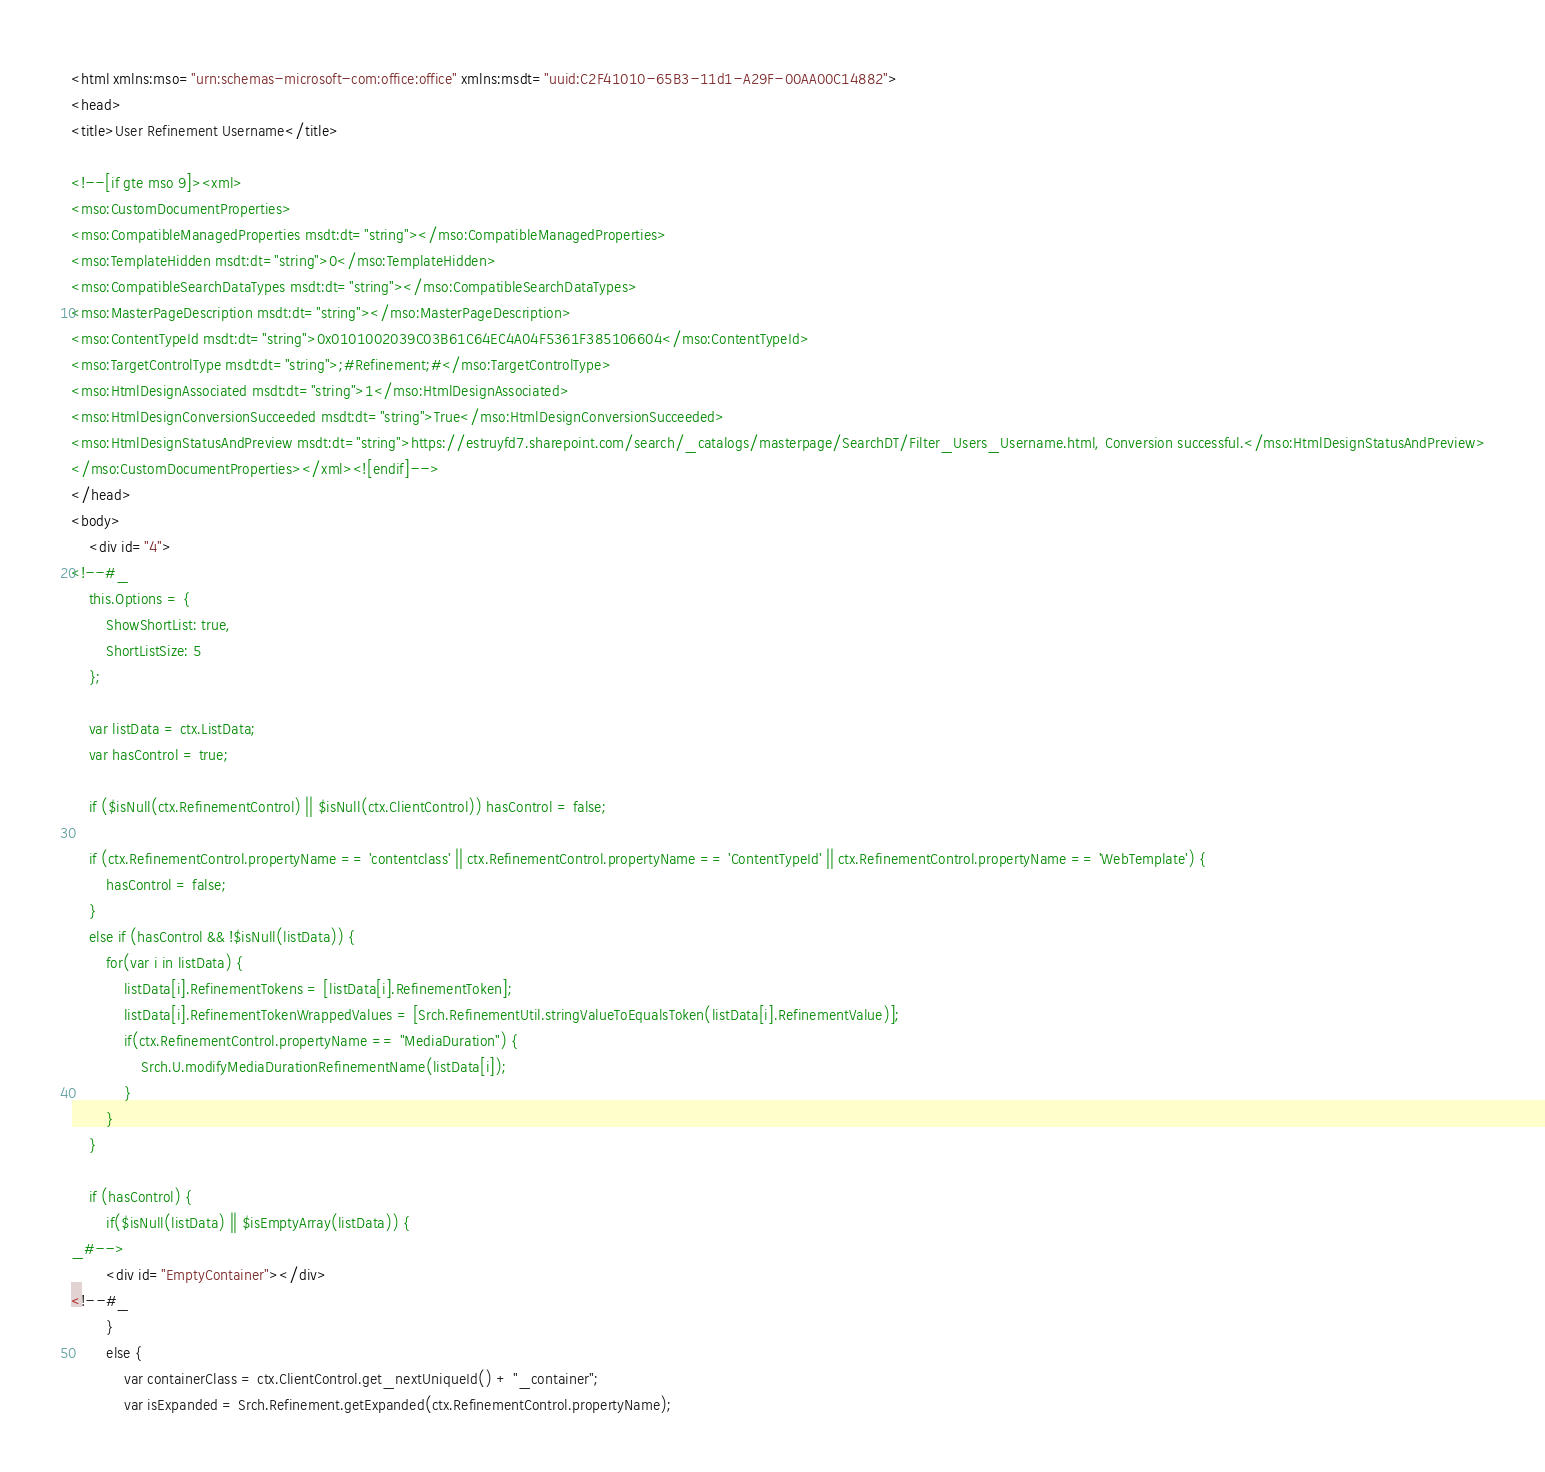<code> <loc_0><loc_0><loc_500><loc_500><_HTML_><html xmlns:mso="urn:schemas-microsoft-com:office:office" xmlns:msdt="uuid:C2F41010-65B3-11d1-A29F-00AA00C14882"> 
<head>
<title>User Refinement Username</title>

<!--[if gte mso 9]><xml>
<mso:CustomDocumentProperties>
<mso:CompatibleManagedProperties msdt:dt="string"></mso:CompatibleManagedProperties>
<mso:TemplateHidden msdt:dt="string">0</mso:TemplateHidden>
<mso:CompatibleSearchDataTypes msdt:dt="string"></mso:CompatibleSearchDataTypes>
<mso:MasterPageDescription msdt:dt="string"></mso:MasterPageDescription>
<mso:ContentTypeId msdt:dt="string">0x0101002039C03B61C64EC4A04F5361F385106604</mso:ContentTypeId>
<mso:TargetControlType msdt:dt="string">;#Refinement;#</mso:TargetControlType>
<mso:HtmlDesignAssociated msdt:dt="string">1</mso:HtmlDesignAssociated>
<mso:HtmlDesignConversionSucceeded msdt:dt="string">True</mso:HtmlDesignConversionSucceeded>
<mso:HtmlDesignStatusAndPreview msdt:dt="string">https://estruyfd7.sharepoint.com/search/_catalogs/masterpage/SearchDT/Filter_Users_Username.html, Conversion successful.</mso:HtmlDesignStatusAndPreview>
</mso:CustomDocumentProperties></xml><![endif]-->
</head>
<body>
    <div id="4">
<!--#_
    this.Options = {
        ShowShortList: true,
        ShortListSize: 5
    };

    var listData = ctx.ListData;
    var hasControl = true;

    if ($isNull(ctx.RefinementControl) || $isNull(ctx.ClientControl)) hasControl = false;

    if (ctx.RefinementControl.propertyName == 'contentclass' || ctx.RefinementControl.propertyName == 'ContentTypeId' || ctx.RefinementControl.propertyName == 'WebTemplate') {
        hasControl = false;
    }
    else if (hasControl && !$isNull(listData)) {
        for(var i in listData) {
            listData[i].RefinementTokens = [listData[i].RefinementToken];
            listData[i].RefinementTokenWrappedValues = [Srch.RefinementUtil.stringValueToEqualsToken(listData[i].RefinementValue)];
            if(ctx.RefinementControl.propertyName == "MediaDuration") {
                Srch.U.modifyMediaDurationRefinementName(listData[i]);
            }
        }
    }

    if (hasControl) {
        if($isNull(listData) || $isEmptyArray(listData)) {
_#-->
        <div id="EmptyContainer"></div>
<!--#_
        }
        else {
            var containerClass = ctx.ClientControl.get_nextUniqueId() + "_container";
            var isExpanded = Srch.Refinement.getExpanded(ctx.RefinementControl.propertyName);</code> 